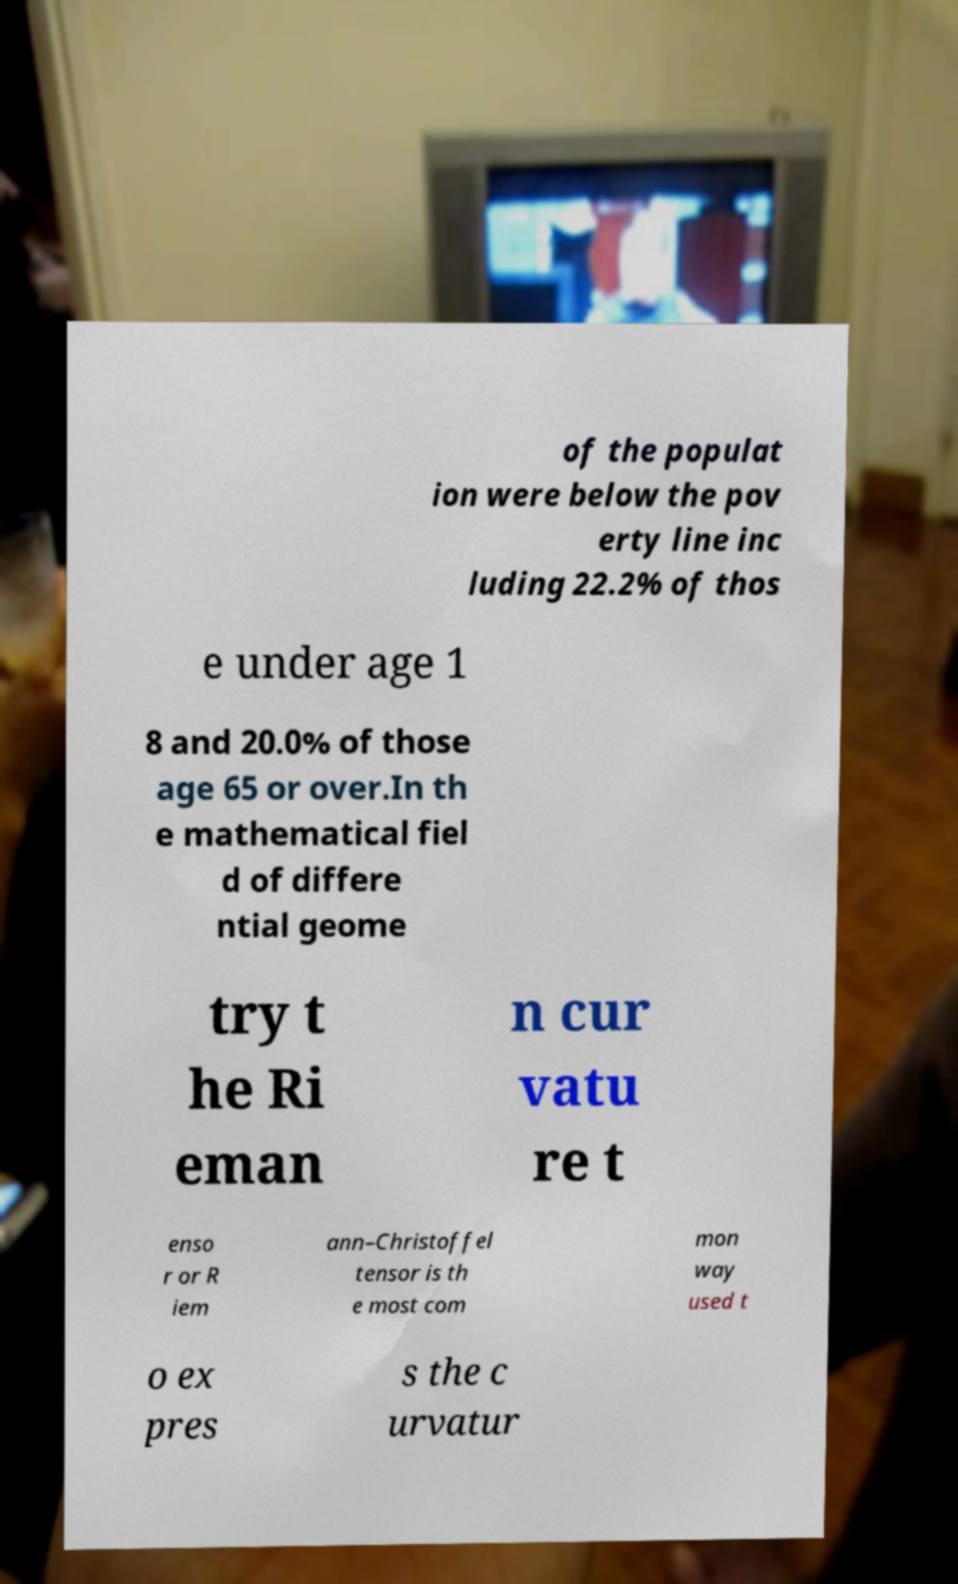There's text embedded in this image that I need extracted. Can you transcribe it verbatim? of the populat ion were below the pov erty line inc luding 22.2% of thos e under age 1 8 and 20.0% of those age 65 or over.In th e mathematical fiel d of differe ntial geome try t he Ri eman n cur vatu re t enso r or R iem ann–Christoffel tensor is th e most com mon way used t o ex pres s the c urvatur 